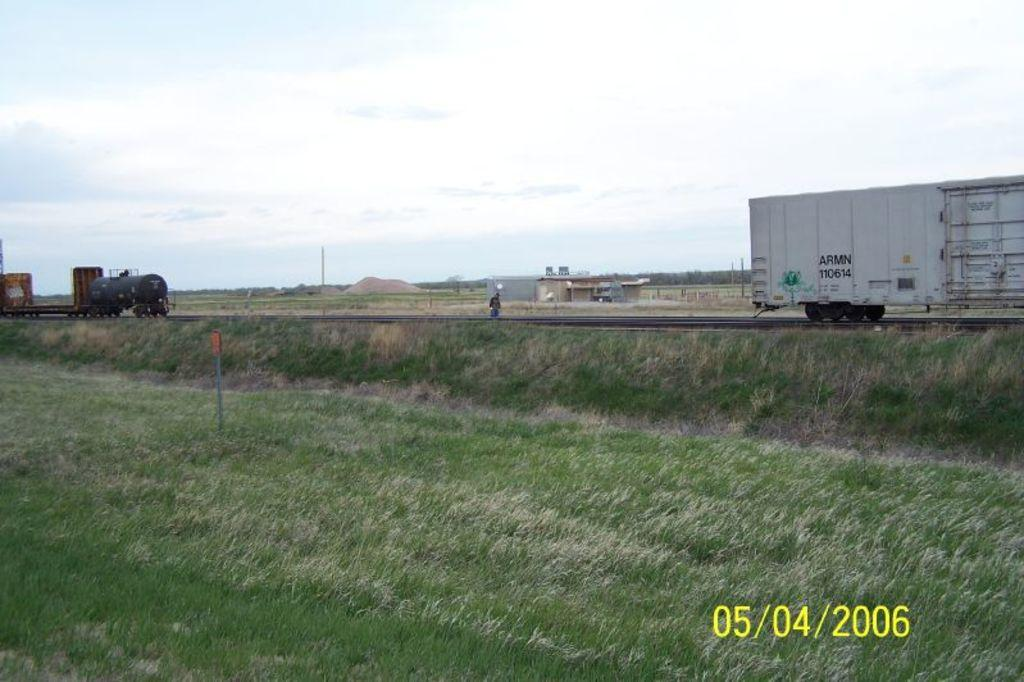What can be seen on the road in the image? There are vehicles on the road in the image. What is visible in the background of the image? There are buildings and trees in the background of the image. What type of vegetation is in the foreground of the image? There is grass in the foreground of the image. How many wishes can be granted by the dime in the image? There is no dime present in the image, so it is not possible to grant any wishes. What type of flight is depicted in the image? There is no flight or any reference to flying objects in the image. 